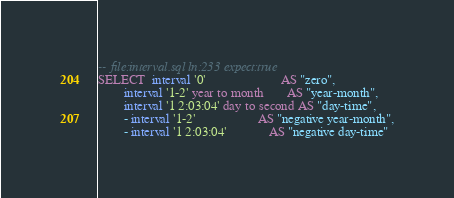Convert code to text. <code><loc_0><loc_0><loc_500><loc_500><_SQL_>-- file:interval.sql ln:233 expect:true
SELECT  interval '0'                       AS "zero",
        interval '1-2' year to month       AS "year-month",
        interval '1 2:03:04' day to second AS "day-time",
        - interval '1-2'                   AS "negative year-month",
        - interval '1 2:03:04'             AS "negative day-time"
</code> 